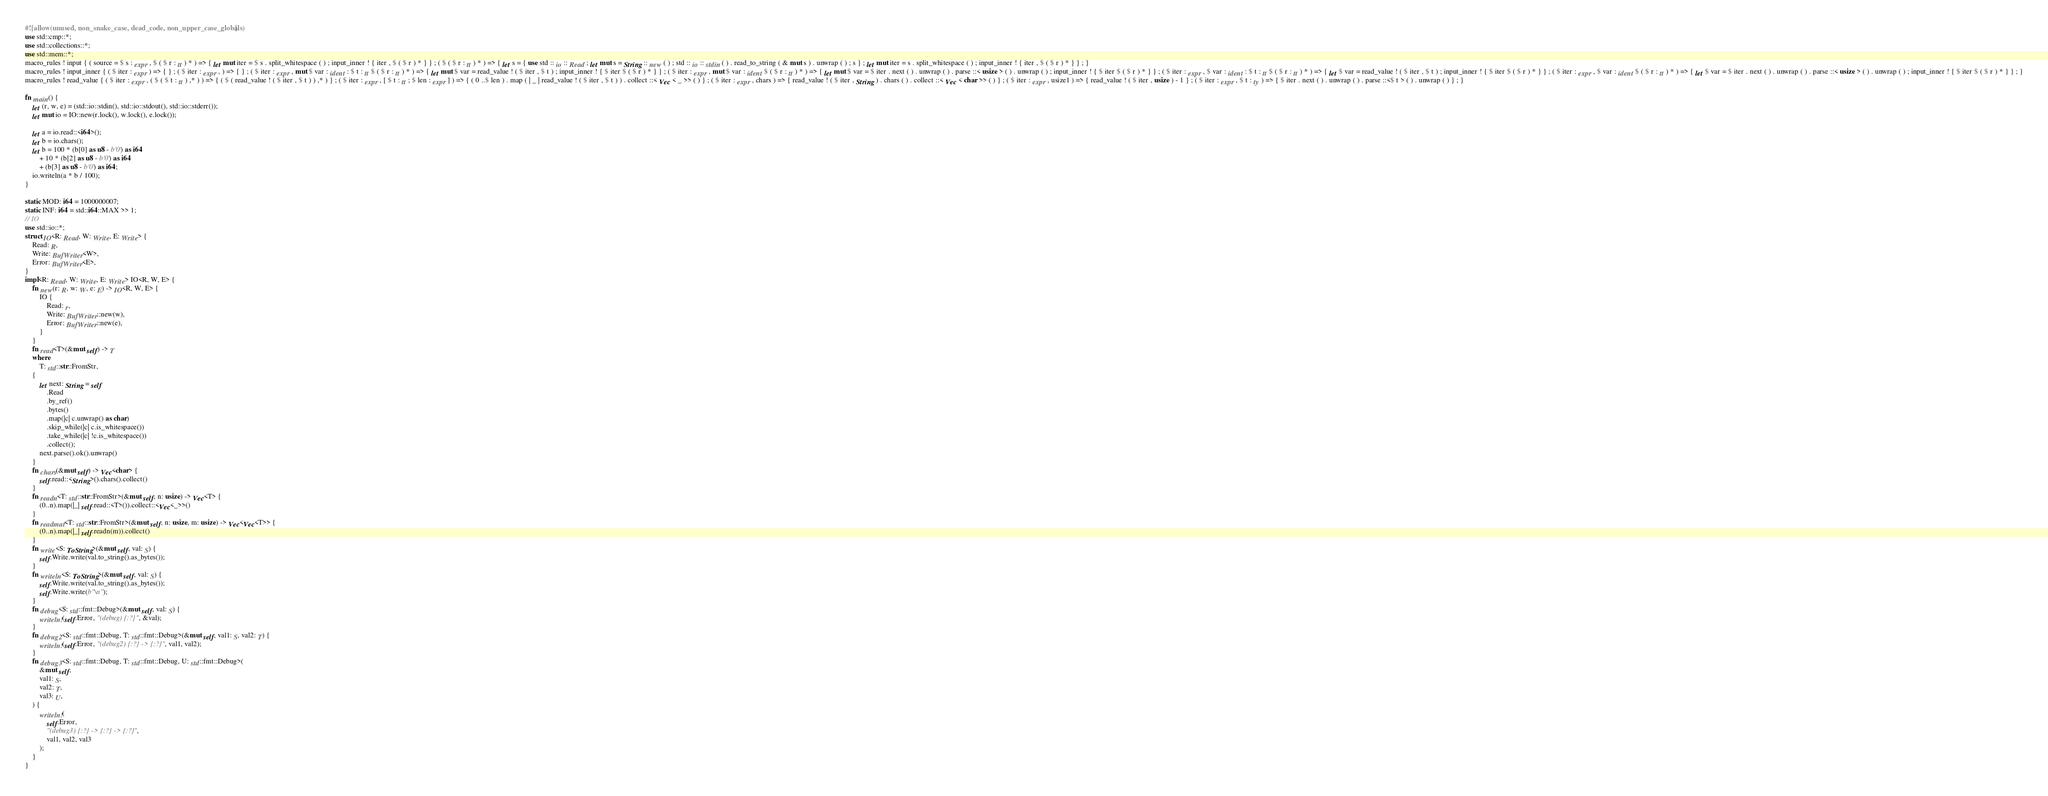<code> <loc_0><loc_0><loc_500><loc_500><_Rust_>#![allow(unused, non_snake_case, dead_code, non_upper_case_globals)]
use std::cmp::*;
use std::collections::*;
use std::mem::*;
macro_rules ! input { ( source = $ s : expr , $ ( $ r : tt ) * ) => { let mut iter = $ s . split_whitespace ( ) ; input_inner ! { iter , $ ( $ r ) * } } ; ( $ ( $ r : tt ) * ) => { let s = { use std :: io :: Read ; let mut s = String :: new ( ) ; std :: io :: stdin ( ) . read_to_string ( & mut s ) . unwrap ( ) ; s } ; let mut iter = s . split_whitespace ( ) ; input_inner ! { iter , $ ( $ r ) * } } ; }
macro_rules ! input_inner { ( $ iter : expr ) => { } ; ( $ iter : expr , ) => { } ; ( $ iter : expr , mut $ var : ident : $ t : tt $ ( $ r : tt ) * ) => { let mut $ var = read_value ! ( $ iter , $ t ) ; input_inner ! { $ iter $ ( $ r ) * } } ; ( $ iter : expr , mut $ var : ident $ ( $ r : tt ) * ) => { let mut $ var = $ iter . next ( ) . unwrap ( ) . parse ::< usize > ( ) . unwrap ( ) ; input_inner ! { $ iter $ ( $ r ) * } } ; ( $ iter : expr , $ var : ident : $ t : tt $ ( $ r : tt ) * ) => { let $ var = read_value ! ( $ iter , $ t ) ; input_inner ! { $ iter $ ( $ r ) * } } ; ( $ iter : expr , $ var : ident $ ( $ r : tt ) * ) => { let $ var = $ iter . next ( ) . unwrap ( ) . parse ::< usize > ( ) . unwrap ( ) ; input_inner ! { $ iter $ ( $ r ) * } } ; }
macro_rules ! read_value { ( $ iter : expr , ( $ ( $ t : tt ) ,* ) ) => { ( $ ( read_value ! ( $ iter , $ t ) ) ,* ) } ; ( $ iter : expr , [ $ t : tt ; $ len : expr ] ) => { ( 0 ..$ len ) . map ( | _ | read_value ! ( $ iter , $ t ) ) . collect ::< Vec < _ >> ( ) } ; ( $ iter : expr , chars ) => { read_value ! ( $ iter , String ) . chars ( ) . collect ::< Vec < char >> ( ) } ; ( $ iter : expr , usize1 ) => { read_value ! ( $ iter , usize ) - 1 } ; ( $ iter : expr , $ t : ty ) => { $ iter . next ( ) . unwrap ( ) . parse ::<$ t > ( ) . unwrap ( ) } ; }

fn main() {
    let (r, w, e) = (std::io::stdin(), std::io::stdout(), std::io::stderr());
    let mut io = IO::new(r.lock(), w.lock(), e.lock());

    let a = io.read::<i64>();
    let b = io.chars();
    let b = 100 * (b[0] as u8 - b'0') as i64
        + 10 * (b[2] as u8 - b'0') as i64
        + (b[3] as u8 - b'0') as i64;
    io.writeln(a * b / 100);
}

static MOD: i64 = 1000000007;
static INF: i64 = std::i64::MAX >> 1;
// IO
use std::io::*;
struct IO<R: Read, W: Write, E: Write> {
    Read: R,
    Write: BufWriter<W>,
    Error: BufWriter<E>,
}
impl<R: Read, W: Write, E: Write> IO<R, W, E> {
    fn new(r: R, w: W, e: E) -> IO<R, W, E> {
        IO {
            Read: r,
            Write: BufWriter::new(w),
            Error: BufWriter::new(e),
        }
    }
    fn read<T>(&mut self) -> T
    where
        T: std::str::FromStr,
    {
        let next: String = self
            .Read
            .by_ref()
            .bytes()
            .map(|c| c.unwrap() as char)
            .skip_while(|c| c.is_whitespace())
            .take_while(|c| !c.is_whitespace())
            .collect();
        next.parse().ok().unwrap()
    }
    fn chars(&mut self) -> Vec<char> {
        self.read::<String>().chars().collect()
    }
    fn readn<T: std::str::FromStr>(&mut self, n: usize) -> Vec<T> {
        (0..n).map(|_| self.read::<T>()).collect::<Vec<_>>()
    }
    fn readmat<T: std::str::FromStr>(&mut self, n: usize, m: usize) -> Vec<Vec<T>> {
        (0..n).map(|_| self.readn(m)).collect()
    }
    fn write<S: ToString>(&mut self, val: S) {
        self.Write.write(val.to_string().as_bytes());
    }
    fn writeln<S: ToString>(&mut self, val: S) {
        self.Write.write(val.to_string().as_bytes());
        self.Write.write(b"\n");
    }
    fn debug<S: std::fmt::Debug>(&mut self, val: S) {
        writeln!(self.Error, "(debug) {:?}", &val);
    }
    fn debug2<S: std::fmt::Debug, T: std::fmt::Debug>(&mut self, val1: S, val2: T) {
        writeln!(self.Error, "(debug2) {:?} -> {:?}", val1, val2);
    }
    fn debug3<S: std::fmt::Debug, T: std::fmt::Debug, U: std::fmt::Debug>(
        &mut self,
        val1: S,
        val2: T,
        val3: U,
    ) {
        writeln!(
            self.Error,
            "(debug3) {:?} -> {:?} -> {:?}",
            val1, val2, val3
        );
    }
}
</code> 